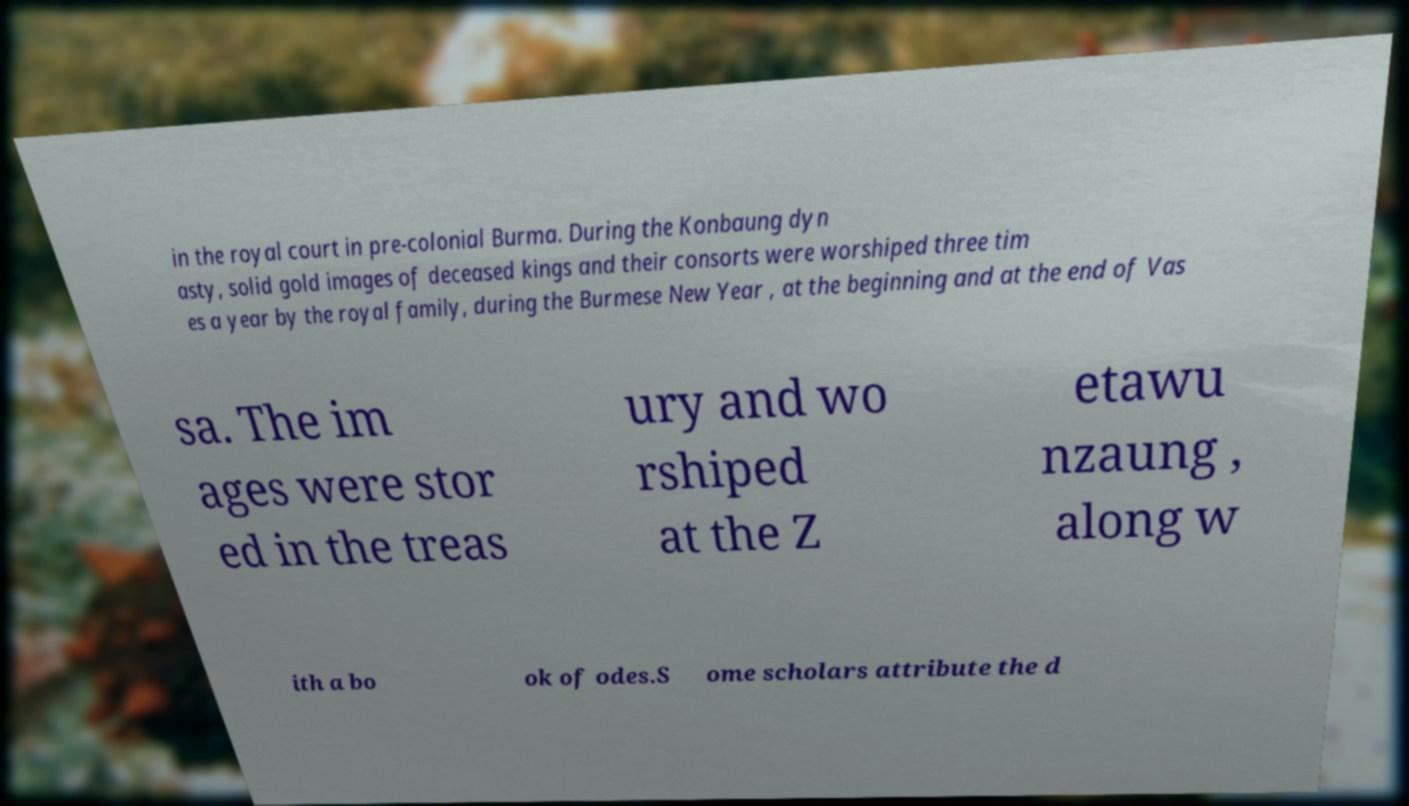I need the written content from this picture converted into text. Can you do that? in the royal court in pre-colonial Burma. During the Konbaung dyn asty, solid gold images of deceased kings and their consorts were worshiped three tim es a year by the royal family, during the Burmese New Year , at the beginning and at the end of Vas sa. The im ages were stor ed in the treas ury and wo rshiped at the Z etawu nzaung , along w ith a bo ok of odes.S ome scholars attribute the d 